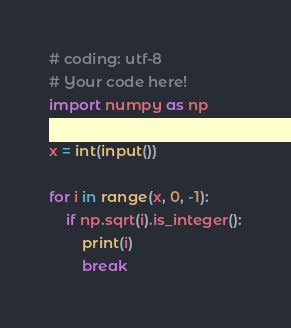<code> <loc_0><loc_0><loc_500><loc_500><_Python_># coding: utf-8
# Your code here!
import numpy as np

x = int(input())

for i in range(x, 0, -1):
    if np.sqrt(i).is_integer():
        print(i)
        break</code> 